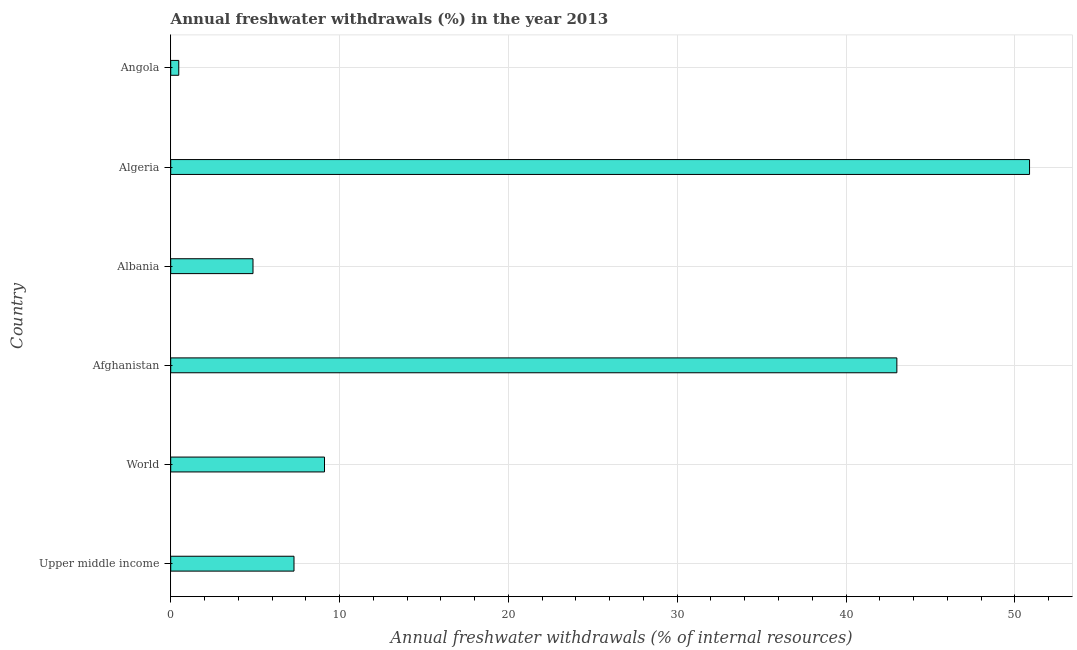Does the graph contain any zero values?
Your answer should be compact. No. Does the graph contain grids?
Keep it short and to the point. Yes. What is the title of the graph?
Your response must be concise. Annual freshwater withdrawals (%) in the year 2013. What is the label or title of the X-axis?
Offer a terse response. Annual freshwater withdrawals (% of internal resources). What is the label or title of the Y-axis?
Offer a very short reply. Country. What is the annual freshwater withdrawals in Afghanistan?
Your answer should be very brief. 43.01. Across all countries, what is the maximum annual freshwater withdrawals?
Keep it short and to the point. 50.87. Across all countries, what is the minimum annual freshwater withdrawals?
Provide a short and direct response. 0.48. In which country was the annual freshwater withdrawals maximum?
Your answer should be compact. Algeria. In which country was the annual freshwater withdrawals minimum?
Make the answer very short. Angola. What is the sum of the annual freshwater withdrawals?
Your answer should be compact. 115.64. What is the difference between the annual freshwater withdrawals in Angola and World?
Keep it short and to the point. -8.63. What is the average annual freshwater withdrawals per country?
Keep it short and to the point. 19.27. What is the median annual freshwater withdrawals?
Ensure brevity in your answer.  8.21. In how many countries, is the annual freshwater withdrawals greater than 46 %?
Provide a short and direct response. 1. What is the ratio of the annual freshwater withdrawals in Afghanistan to that in Upper middle income?
Offer a terse response. 5.89. Is the difference between the annual freshwater withdrawals in Afghanistan and Upper middle income greater than the difference between any two countries?
Your answer should be compact. No. What is the difference between the highest and the second highest annual freshwater withdrawals?
Ensure brevity in your answer.  7.86. Is the sum of the annual freshwater withdrawals in Angola and World greater than the maximum annual freshwater withdrawals across all countries?
Your answer should be compact. No. What is the difference between the highest and the lowest annual freshwater withdrawals?
Make the answer very short. 50.39. In how many countries, is the annual freshwater withdrawals greater than the average annual freshwater withdrawals taken over all countries?
Give a very brief answer. 2. How many bars are there?
Offer a very short reply. 6. Are all the bars in the graph horizontal?
Make the answer very short. Yes. How many countries are there in the graph?
Your response must be concise. 6. Are the values on the major ticks of X-axis written in scientific E-notation?
Your answer should be very brief. No. What is the Annual freshwater withdrawals (% of internal resources) in Upper middle income?
Provide a succinct answer. 7.3. What is the Annual freshwater withdrawals (% of internal resources) in World?
Provide a succinct answer. 9.11. What is the Annual freshwater withdrawals (% of internal resources) in Afghanistan?
Ensure brevity in your answer.  43.01. What is the Annual freshwater withdrawals (% of internal resources) of Albania?
Give a very brief answer. 4.87. What is the Annual freshwater withdrawals (% of internal resources) of Algeria?
Your response must be concise. 50.87. What is the Annual freshwater withdrawals (% of internal resources) in Angola?
Your answer should be very brief. 0.48. What is the difference between the Annual freshwater withdrawals (% of internal resources) in Upper middle income and World?
Your answer should be compact. -1.81. What is the difference between the Annual freshwater withdrawals (% of internal resources) in Upper middle income and Afghanistan?
Provide a short and direct response. -35.71. What is the difference between the Annual freshwater withdrawals (% of internal resources) in Upper middle income and Albania?
Give a very brief answer. 2.43. What is the difference between the Annual freshwater withdrawals (% of internal resources) in Upper middle income and Algeria?
Offer a very short reply. -43.57. What is the difference between the Annual freshwater withdrawals (% of internal resources) in Upper middle income and Angola?
Your response must be concise. 6.83. What is the difference between the Annual freshwater withdrawals (% of internal resources) in World and Afghanistan?
Provide a short and direct response. -33.9. What is the difference between the Annual freshwater withdrawals (% of internal resources) in World and Albania?
Provide a short and direct response. 4.24. What is the difference between the Annual freshwater withdrawals (% of internal resources) in World and Algeria?
Make the answer very short. -41.76. What is the difference between the Annual freshwater withdrawals (% of internal resources) in World and Angola?
Give a very brief answer. 8.63. What is the difference between the Annual freshwater withdrawals (% of internal resources) in Afghanistan and Albania?
Provide a short and direct response. 38.14. What is the difference between the Annual freshwater withdrawals (% of internal resources) in Afghanistan and Algeria?
Offer a terse response. -7.86. What is the difference between the Annual freshwater withdrawals (% of internal resources) in Afghanistan and Angola?
Keep it short and to the point. 42.53. What is the difference between the Annual freshwater withdrawals (% of internal resources) in Albania and Algeria?
Give a very brief answer. -46. What is the difference between the Annual freshwater withdrawals (% of internal resources) in Albania and Angola?
Your answer should be very brief. 4.4. What is the difference between the Annual freshwater withdrawals (% of internal resources) in Algeria and Angola?
Keep it short and to the point. 50.39. What is the ratio of the Annual freshwater withdrawals (% of internal resources) in Upper middle income to that in World?
Ensure brevity in your answer.  0.8. What is the ratio of the Annual freshwater withdrawals (% of internal resources) in Upper middle income to that in Afghanistan?
Offer a terse response. 0.17. What is the ratio of the Annual freshwater withdrawals (% of internal resources) in Upper middle income to that in Albania?
Your answer should be very brief. 1.5. What is the ratio of the Annual freshwater withdrawals (% of internal resources) in Upper middle income to that in Algeria?
Make the answer very short. 0.14. What is the ratio of the Annual freshwater withdrawals (% of internal resources) in Upper middle income to that in Angola?
Offer a terse response. 15.31. What is the ratio of the Annual freshwater withdrawals (% of internal resources) in World to that in Afghanistan?
Make the answer very short. 0.21. What is the ratio of the Annual freshwater withdrawals (% of internal resources) in World to that in Albania?
Give a very brief answer. 1.87. What is the ratio of the Annual freshwater withdrawals (% of internal resources) in World to that in Algeria?
Offer a terse response. 0.18. What is the ratio of the Annual freshwater withdrawals (% of internal resources) in World to that in Angola?
Give a very brief answer. 19.1. What is the ratio of the Annual freshwater withdrawals (% of internal resources) in Afghanistan to that in Albania?
Provide a succinct answer. 8.82. What is the ratio of the Annual freshwater withdrawals (% of internal resources) in Afghanistan to that in Algeria?
Give a very brief answer. 0.85. What is the ratio of the Annual freshwater withdrawals (% of internal resources) in Afghanistan to that in Angola?
Keep it short and to the point. 90.19. What is the ratio of the Annual freshwater withdrawals (% of internal resources) in Albania to that in Algeria?
Provide a succinct answer. 0.1. What is the ratio of the Annual freshwater withdrawals (% of internal resources) in Albania to that in Angola?
Provide a short and direct response. 10.22. What is the ratio of the Annual freshwater withdrawals (% of internal resources) in Algeria to that in Angola?
Keep it short and to the point. 106.67. 